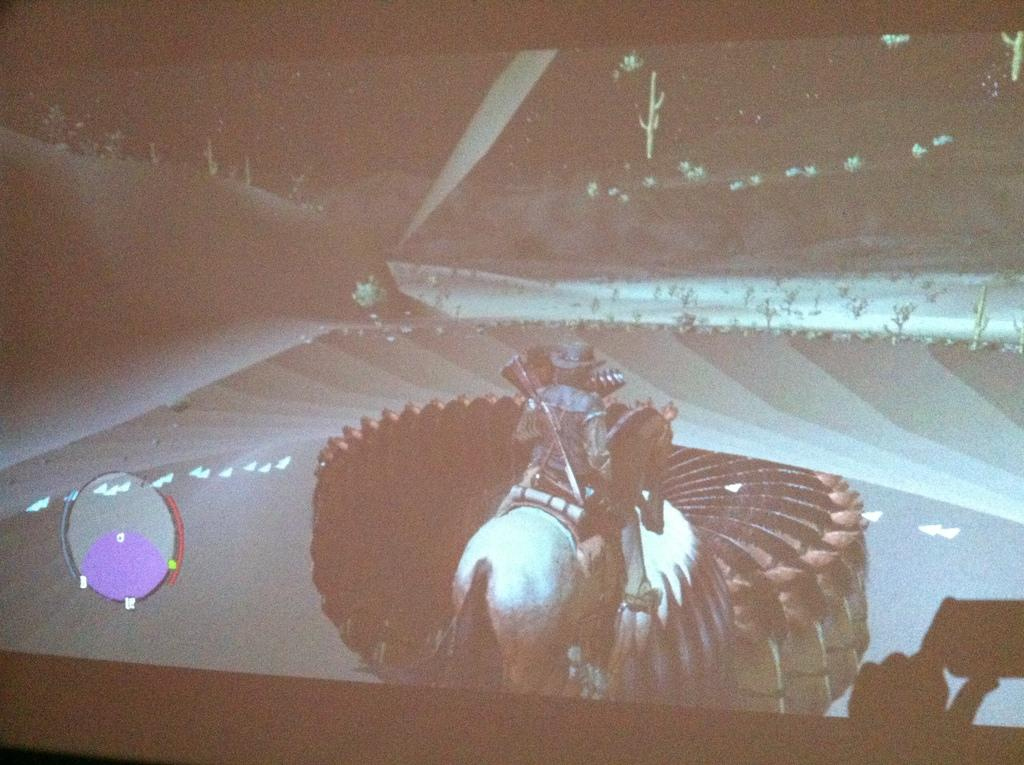What is the main object in the image? There is a screen in the image. What is being displayed on the screen? The screen displays an animated picture. What is happening in the animated picture? The animated picture features a person sitting on a horse. Are there any other elements in the animated picture? Yes, there are other objects visible in the animated picture. Can you tell me how many visitors are present in the image? There are no visitors present in the image; it features a screen displaying an animated picture. Is there a bomb visible in the animated picture? There is no bomb visible in the animated picture; it features a person sitting on a horse and other objects. 